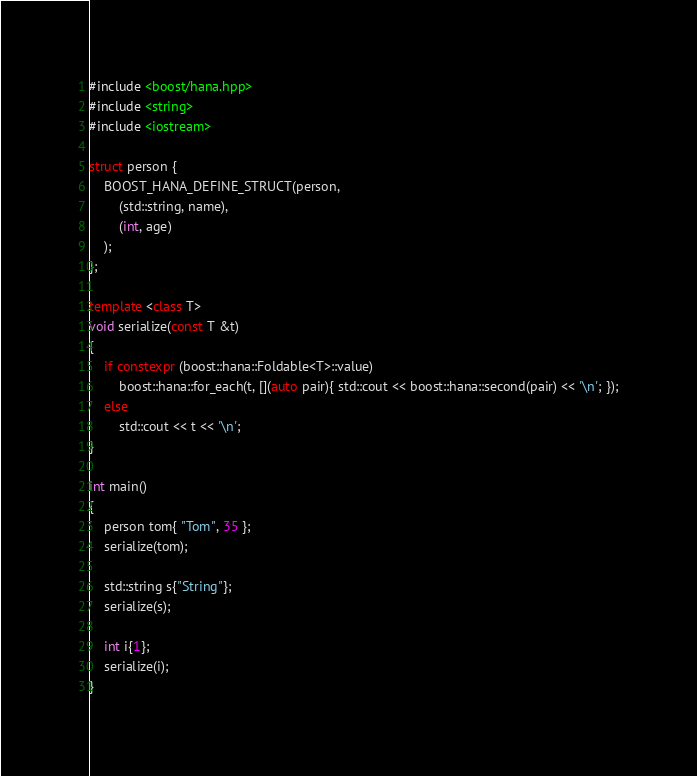Convert code to text. <code><loc_0><loc_0><loc_500><loc_500><_C++_>#include <boost/hana.hpp>
#include <string>
#include <iostream>

struct person {
    BOOST_HANA_DEFINE_STRUCT(person,
        (std::string, name),
        (int, age)
    );
};

template <class T>
void serialize(const T &t)
{
    if constexpr (boost::hana::Foldable<T>::value)
        boost::hana::for_each(t, [](auto pair){ std::cout << boost::hana::second(pair) << '\n'; });
    else
        std::cout << t << '\n';
}

int main()
{
    person tom{ "Tom", 35 };
    serialize(tom);

    std::string s{"String"};
    serialize(s);

    int i{1};
    serialize(i);
}
</code> 